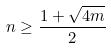<formula> <loc_0><loc_0><loc_500><loc_500>n \geq \frac { 1 + \sqrt { 4 m } } { 2 }</formula> 